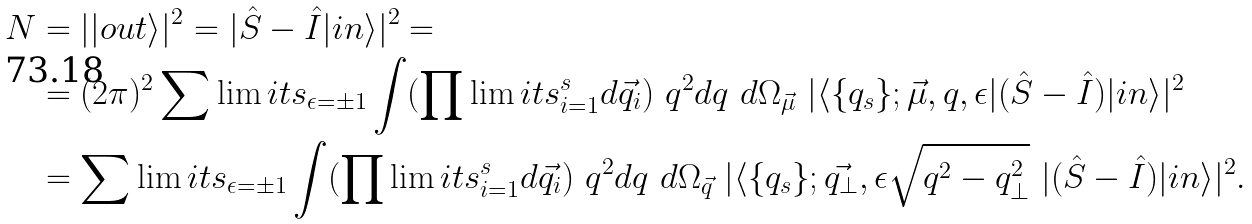Convert formula to latex. <formula><loc_0><loc_0><loc_500><loc_500>N & = | | o u t \rangle | ^ { 2 } = | \hat { S } - \hat { I } | i n \rangle | ^ { 2 } = \\ & = ( 2 \pi ) ^ { 2 } \sum \lim i t s _ { \epsilon = \pm 1 } \int ( \prod \lim i t s ^ { s } _ { i = 1 } d \vec { q _ { i } } ) \ q ^ { 2 } d q \ d \Omega _ { \vec { \mu } } \ | \langle \{ q _ { s } \} ; \vec { \mu } , q , \epsilon | ( \hat { S } - \hat { I } ) | i n \rangle | ^ { 2 } \\ & = \sum \lim i t s _ { \epsilon = \pm 1 } \int ( \prod \lim i t s ^ { s } _ { i = 1 } d \vec { q _ { i } } ) \ q ^ { 2 } d q \ d \Omega _ { \vec { q } } \ | \langle \{ q _ { s } \} ; \vec { q _ { \bot } } , \epsilon \sqrt { q ^ { 2 } - q ^ { 2 } _ { \bot } } \ | ( \hat { S } - \hat { I } ) | i n \rangle | ^ { 2 } .</formula> 